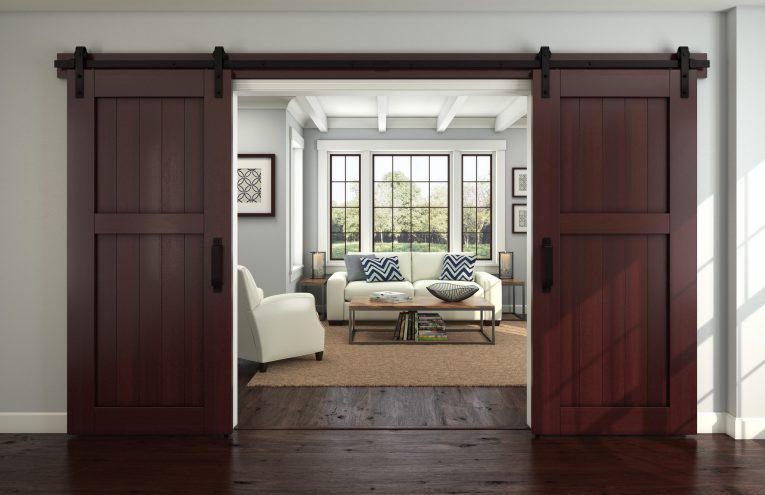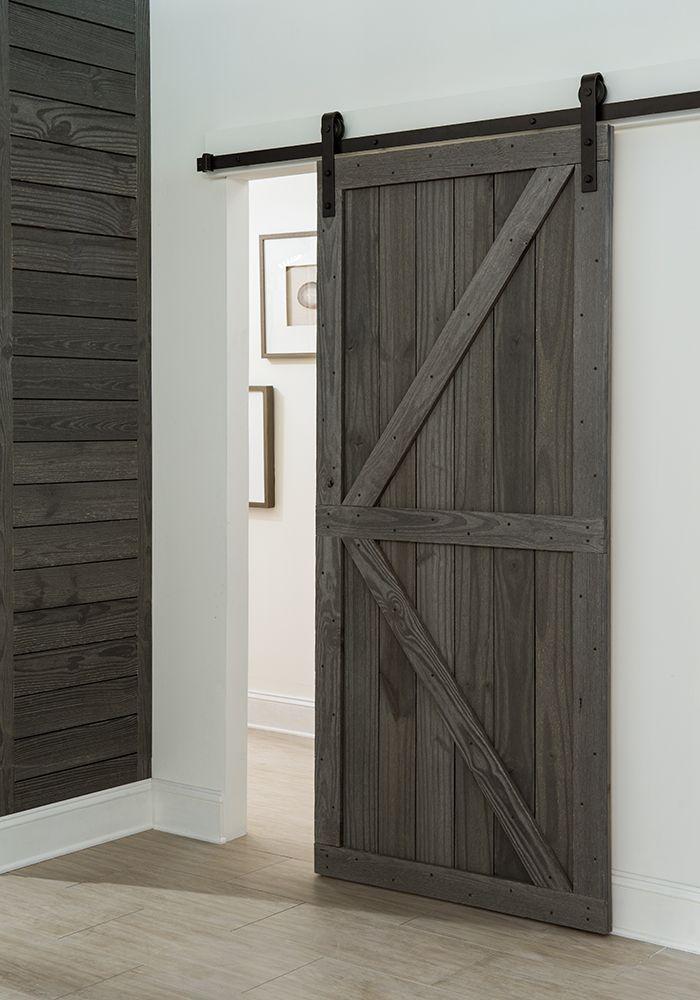The first image is the image on the left, the second image is the image on the right. For the images displayed, is the sentence "The left and right image contains the same number of hanging doors with at least one white wooden door." factually correct? Answer yes or no. No. The first image is the image on the left, the second image is the image on the right. Assess this claim about the two images: "There are multiple doors in one image.". Correct or not? Answer yes or no. Yes. 